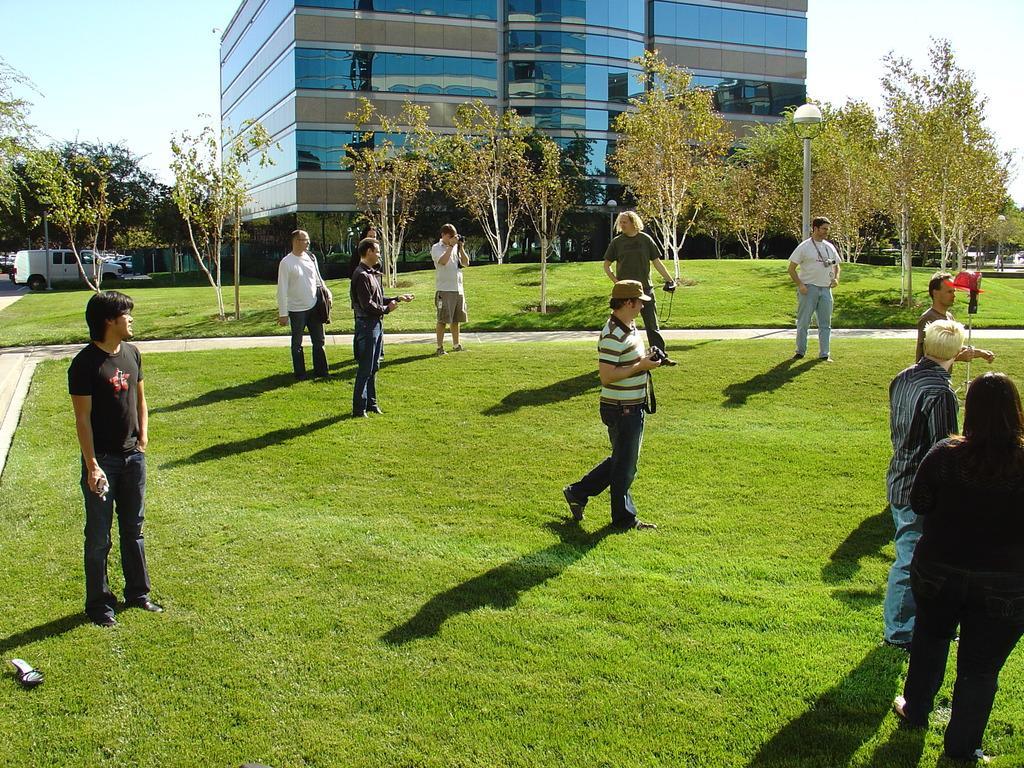Please provide a concise description of this image. In this image there are so many people standing on the grass ground beside that there are so many trees, building and vehicle on road. 